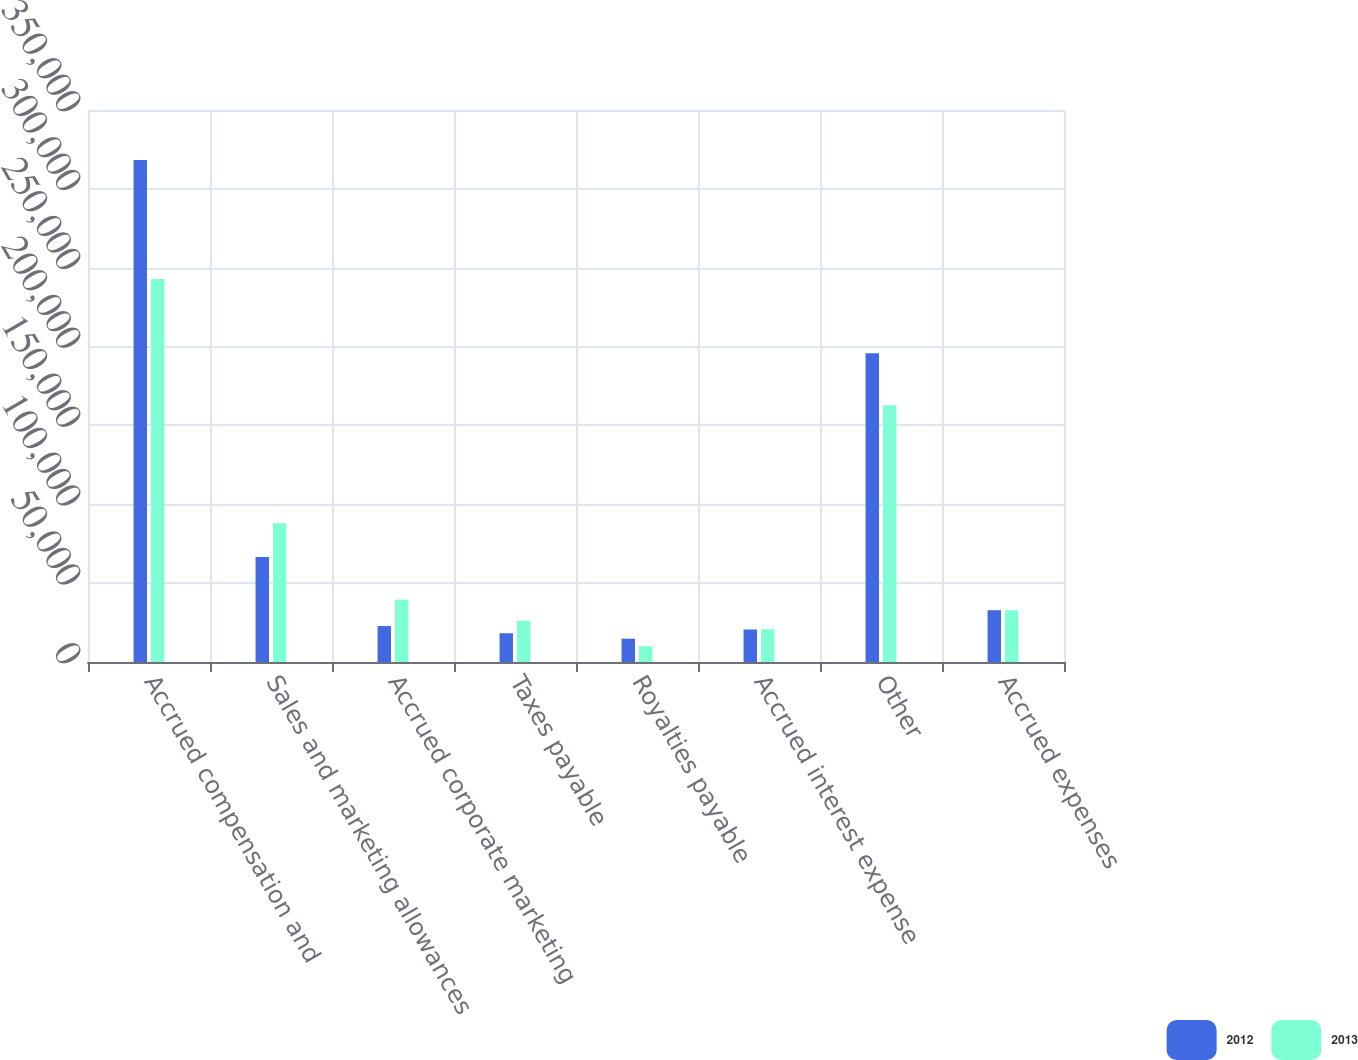Convert chart. <chart><loc_0><loc_0><loc_500><loc_500><stacked_bar_chart><ecel><fcel>Accrued compensation and<fcel>Sales and marketing allowances<fcel>Accrued corporate marketing<fcel>Taxes payable<fcel>Royalties payable<fcel>Accrued interest expense<fcel>Other<fcel>Accrued expenses<nl><fcel>2012<fcel>318219<fcel>66502<fcel>22801<fcel>18225<fcel>14778<fcel>20613<fcel>195801<fcel>32833.5<nl><fcel>2013<fcel>242887<fcel>87916<fcel>39503<fcel>26164<fcel>10040<fcel>20796<fcel>162834<fcel>32833.5<nl></chart> 